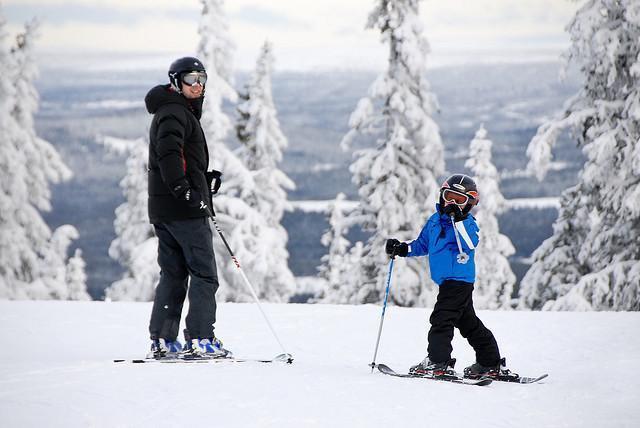How many people are in the picture?
Give a very brief answer. 2. How many dogs she's holding?
Give a very brief answer. 0. 